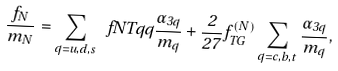<formula> <loc_0><loc_0><loc_500><loc_500>\frac { f _ { N } } { m _ { N } } = \sum _ { q = u , d , s } \ f N T q { q } \frac { \alpha _ { 3 q } } { m _ { q } } + \frac { 2 } { 2 7 } f _ { T G } ^ { ( N ) } \sum _ { q = c , b , t } \frac { \alpha _ { 3 q } } { m _ { q } } ,</formula> 